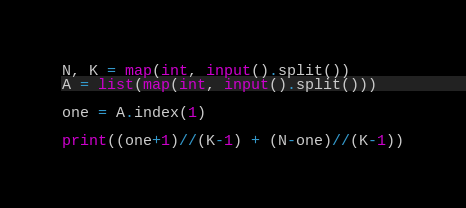Convert code to text. <code><loc_0><loc_0><loc_500><loc_500><_Python_>N, K = map(int, input().split())
A = list(map(int, input().split()))

one = A.index(1)

print((one+1)//(K-1) + (N-one)//(K-1))
</code> 